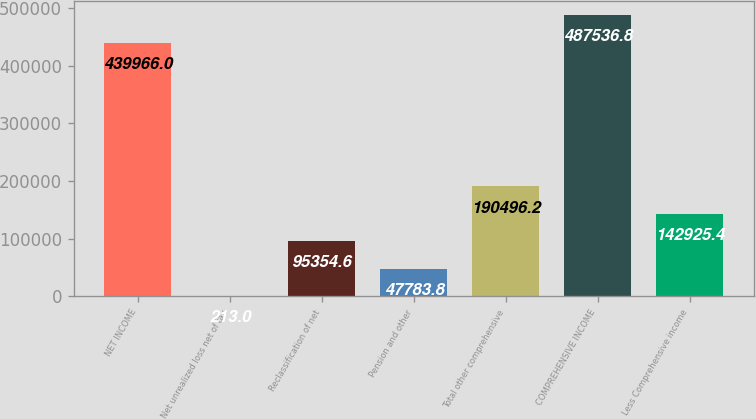<chart> <loc_0><loc_0><loc_500><loc_500><bar_chart><fcel>NET INCOME<fcel>Net unrealized loss net of tax<fcel>Reclassification of net<fcel>Pension and other<fcel>Total other comprehensive<fcel>COMPREHENSIVE INCOME<fcel>Less Comprehensive income<nl><fcel>439966<fcel>213<fcel>95354.6<fcel>47783.8<fcel>190496<fcel>487537<fcel>142925<nl></chart> 